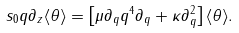<formula> <loc_0><loc_0><loc_500><loc_500>s _ { 0 } q \partial _ { z } \langle \theta \rangle = \left [ \mu \partial _ { q } q ^ { 4 } \partial _ { q } + \kappa \partial _ { q } ^ { 2 } \right ] \langle \theta \rangle .</formula> 